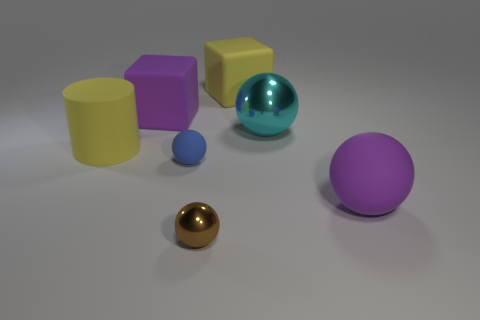Add 2 rubber cylinders. How many objects exist? 9 Subtract all cubes. How many objects are left? 5 Subtract all tiny shiny spheres. Subtract all cylinders. How many objects are left? 5 Add 1 brown metal things. How many brown metal things are left? 2 Add 3 big brown shiny cylinders. How many big brown shiny cylinders exist? 3 Subtract 1 cyan spheres. How many objects are left? 6 